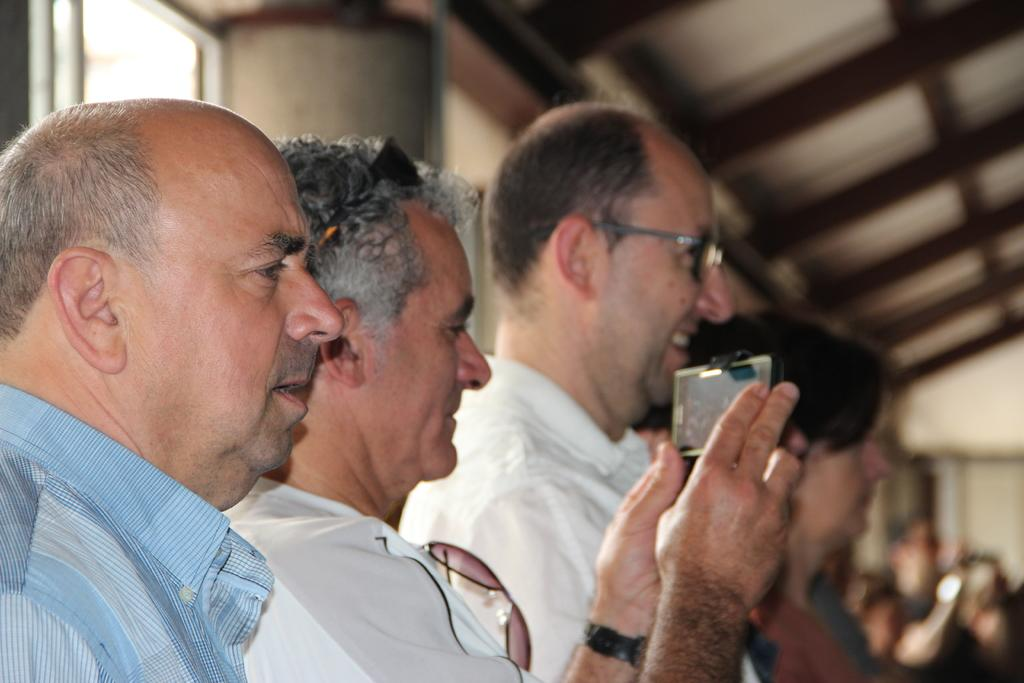How many people are in the image? There are people in the image, but the exact number is not specified. What is one person doing in the image? One person is holding a cell phone. What type of structure can be seen in the image? There is a wall, a window, and a roof in the image. What is the condition of the background in the image? The background of the image is blurred. What type of vest is the minister wearing in the image? There is no minister or vest present in the image. What is the ground like in the image? The ground is not visible in the image; only a wall, window, and roof are shown. 